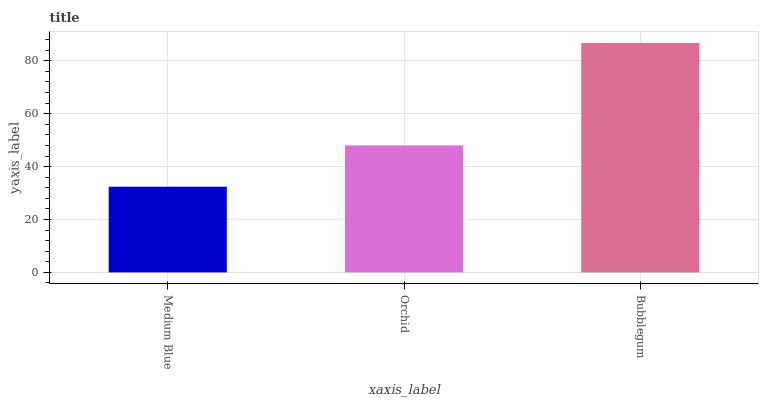Is Orchid the minimum?
Answer yes or no. No. Is Orchid the maximum?
Answer yes or no. No. Is Orchid greater than Medium Blue?
Answer yes or no. Yes. Is Medium Blue less than Orchid?
Answer yes or no. Yes. Is Medium Blue greater than Orchid?
Answer yes or no. No. Is Orchid less than Medium Blue?
Answer yes or no. No. Is Orchid the high median?
Answer yes or no. Yes. Is Orchid the low median?
Answer yes or no. Yes. Is Medium Blue the high median?
Answer yes or no. No. Is Bubblegum the low median?
Answer yes or no. No. 